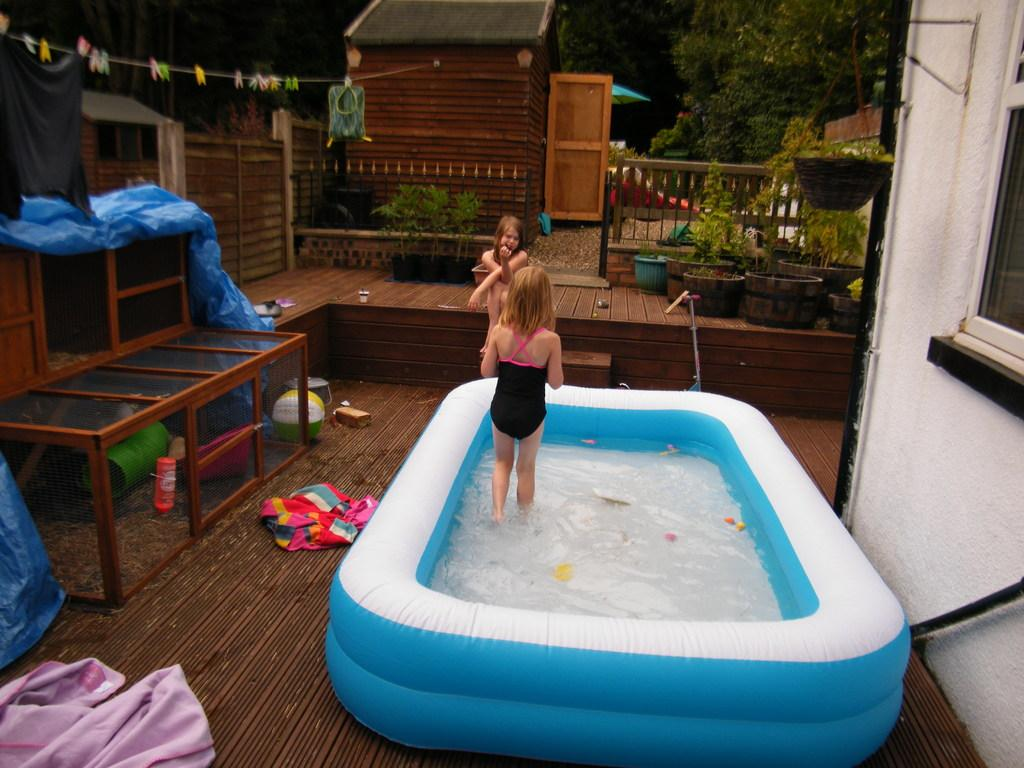What is the main object in the image? There is a portable pool in the image. What are the women doing in the image? One woman is standing in the pool, and another woman is outside the pool. What can be seen in the background of the image? There are trees around the house in the image, and plants are visible. What object is on the floor in the image? There is a ball on the floor. How far is the van from the pool in the image? There is no van present in the image, so it is not possible to determine the distance between a van and the pool. 